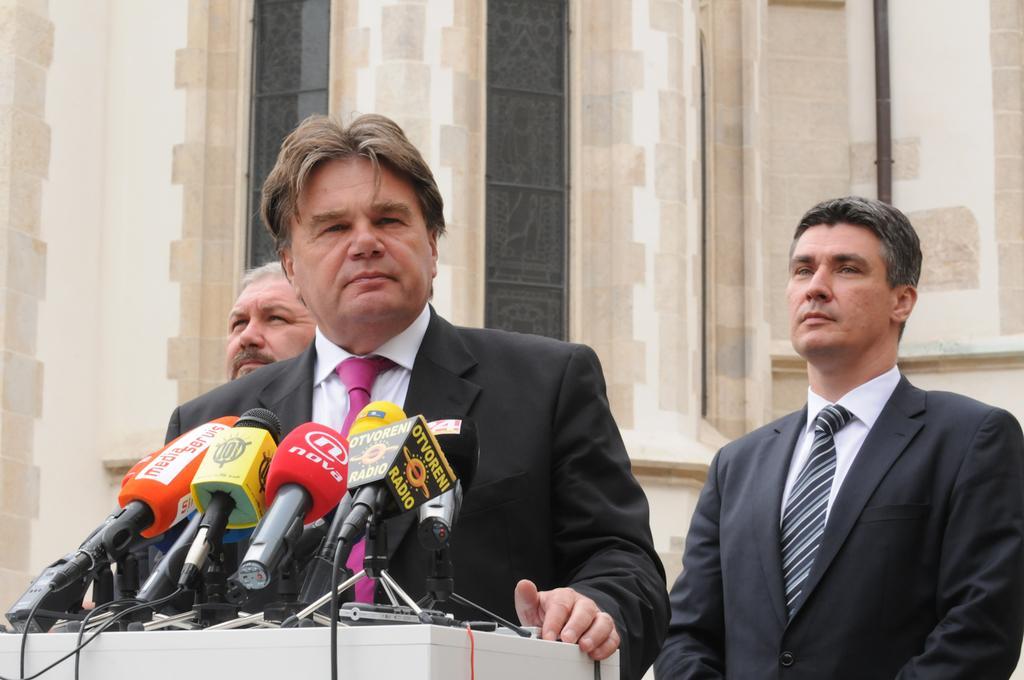In one or two sentences, can you explain what this image depicts? In the foreground of this image, there is a man wearing suit is standing in front of a podium on which there are mics. Behind him, there are two men. In the background, there is a wall of a building. 